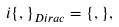<formula> <loc_0><loc_0><loc_500><loc_500>i \{ , \} _ { D i r a c } = \{ , \} ,</formula> 